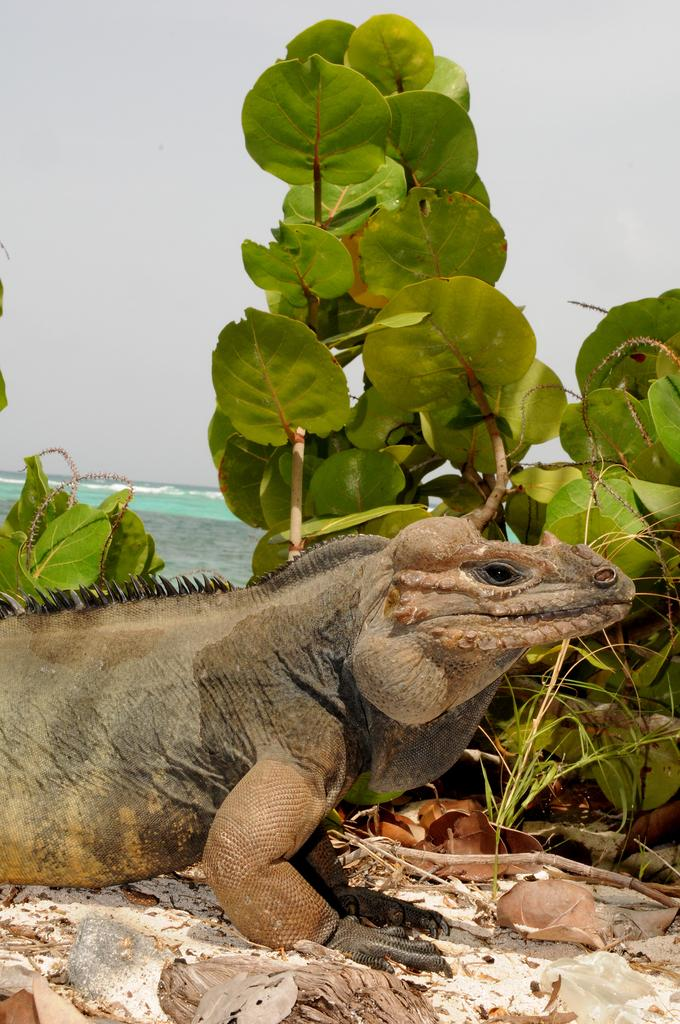What is the main subject in the middle of the picture? There is an iguana in the middle of the picture. What else can be seen in the picture besides the iguana? There are plants in the picture. What can be seen in the background of the picture? The sky is visible in the background of the picture. Where is the door located in the picture? There is no door present in the picture; it features an iguana and plants. What type of cracker is being used as a prop in the image? There is no cracker present in the picture. 